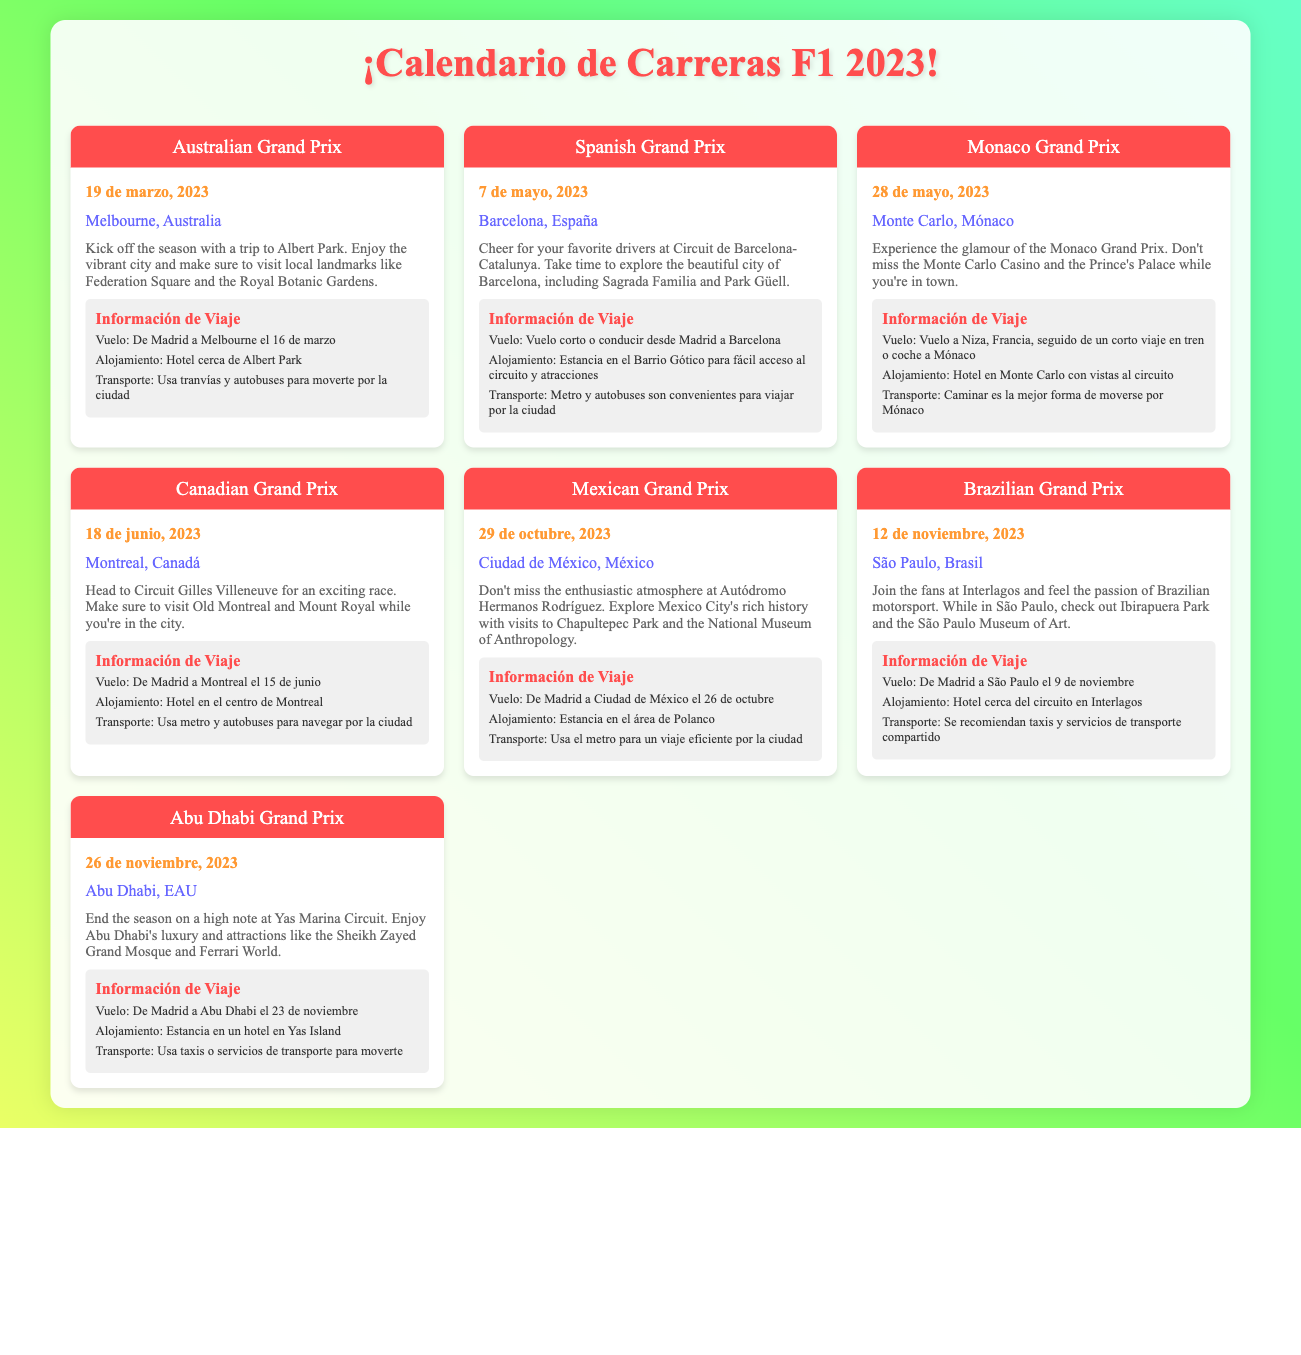¿Cuándo es el Gran Premio de Australia? La fecha del Gran Premio de Australia se encuentra en la sección correspondiente y es el 19 de marzo de 2023.
Answer: 19 de marzo, 2023 ¿Cuál es la ubicación del Gran Premio de Mónaco? La ubicación del Gran Premio de Mónaco está mencionada en su respectiva sección y es Monte Carlo, Mónaco.
Answer: Monte Carlo, Mónaco ¿Qué viaje se sugiere para el Gran Premio de Canadá? La información de viaje para el Gran Premio de Canadá incluye el vuelo y es de Madrid a Montreal el 15 de junio.
Answer: De Madrid a Montreal el 15 de junio ¿Cuál es el hotel recomendado para el Gran Premio de México? En la sección de información de viaje del Gran Premio de México, se menciona que se recomienda alojarse en el área de Polanco.
Answer: Área de Polanco ¿Cuál es el transporte recomendado en Mónaco? La información sobre el transporte para el Gran Premio de Mónaco indica que la mejor forma de moverse es caminando.
Answer: Caminar ¿Cuántas carreras se mencionan en el calendario? Se puede contar el número de carreras en las secciones de "race-card," las cuales representan cada carrera en el documento.
Answer: 7 ¿Qué ciudad se visitará durante el Gran Premio de Brasil? La ubicación mencionada para el Gran Premio de Brasil en la sección correspondiente es São Paulo, Brasil.
Answer: São Paulo, Brasil ¿Cuándo se lleva a cabo el Gran Premio de Abu Dhabi? La fecha del Gran Premio de Abu Dhabi se encuentra en su respectiva sección, que indica que será el 26 de noviembre de 2023.
Answer: 26 de noviembre, 2023 